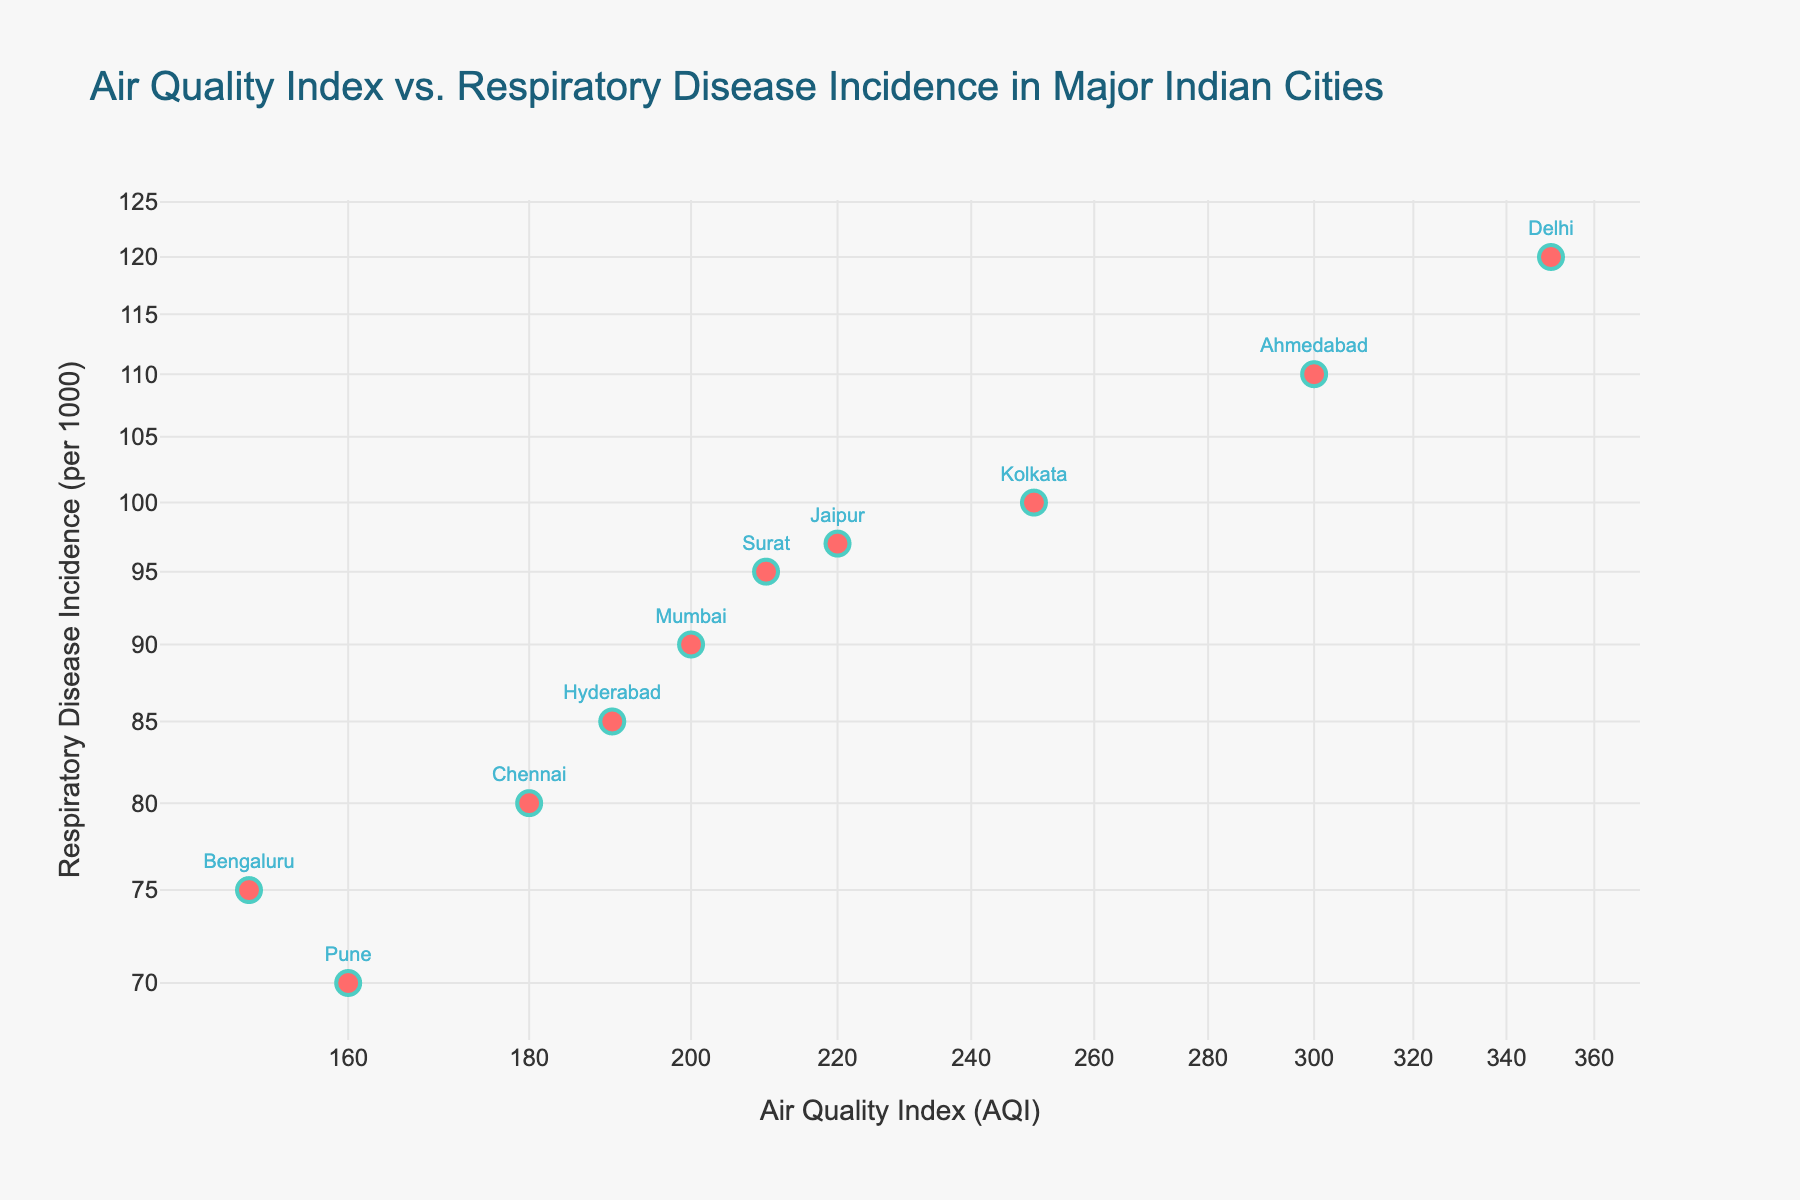How many cities are represented in the scatter plot? By counting the number of unique data points labeled with city names in the scatter plot, we can determine the number of represented cities.
Answer: 10 What is the title of the scatter plot? The title of the scatter plot is usually displayed at the top and provides an overview of the plot's content.
Answer: Air Quality Index vs. Respiratory Disease Incidence in Major Indian Cities Which city has the highest incidence of respiratory diseases? By looking at the y-axis (Incidence of Respiratory Diseases per 1000), find the data point at the highest position and identify the corresponding city label.
Answer: Delhi Compare the AQI of Mumbai and Hyderabad. Which city has a higher AQI? Find the positions of Mumbai and Hyderabad on the x-axis (AQI). By locating both data points, we can see which one is further to the right, indicating a higher AQI.
Answer: Mumbai What is the relationship between AQI and the incidence of respiratory diseases as depicted in the scatter plot? The relationship can be observed by studying the trend of the data points. In a log-log plot, an upward trend from left to right indicates a positive correlation.
Answer: Positive Correlation Determine the average AQI of Delhi and Ahmedabad. First, find the AQI values for both Delhi (350) and Ahmedabad (300). Sum these values (350 + 300 = 650) and then divide by 2 to get the average.
Answer: 325 Which city has the lowest AQI and what is its incidence of respiratory diseases? By identifying the leftmost data point on the x-axis, we find the city with the lowest AQI. Then, look at the corresponding y-axis value for incidence of respiratory diseases.
Answer: Bengaluru, 75 Is there a city with an AQI of around 200 and what is its corresponding incidence of respiratory diseases? Identify the data points near the 200 mark on the x-axis and check the corresponding y-axis values for those cities.
Answer: Mumbai, 90 Between Kolkata and Jaipur, which city has a higher incidence of respiratory diseases? Locate the positions of Kolkata and Jaipur on the y-axis and compare their heights. The city with a higher data point has a higher incidence of respiratory diseases.
Answer: Kolkata What does the color and size of the markers in the scatter plot indicate? From the plot legend or marker description, determine what information is represented by the color and size of the markers.
Answer: Red color and larger size markers are likely highlighting data importance or differentiation, but specifics are not provided 